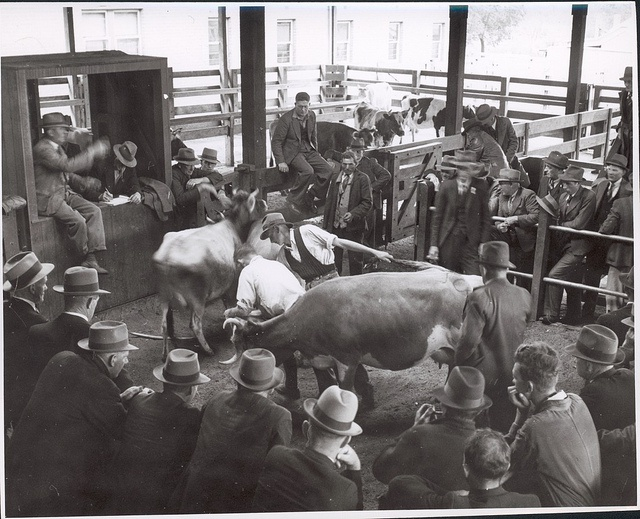Describe the objects in this image and their specific colors. I can see people in black, gray, and darkgray tones, cow in black, gray, darkgray, and lightgray tones, people in black, gray, and darkgray tones, people in black, gray, and darkgray tones, and people in black, gray, and darkgray tones in this image. 